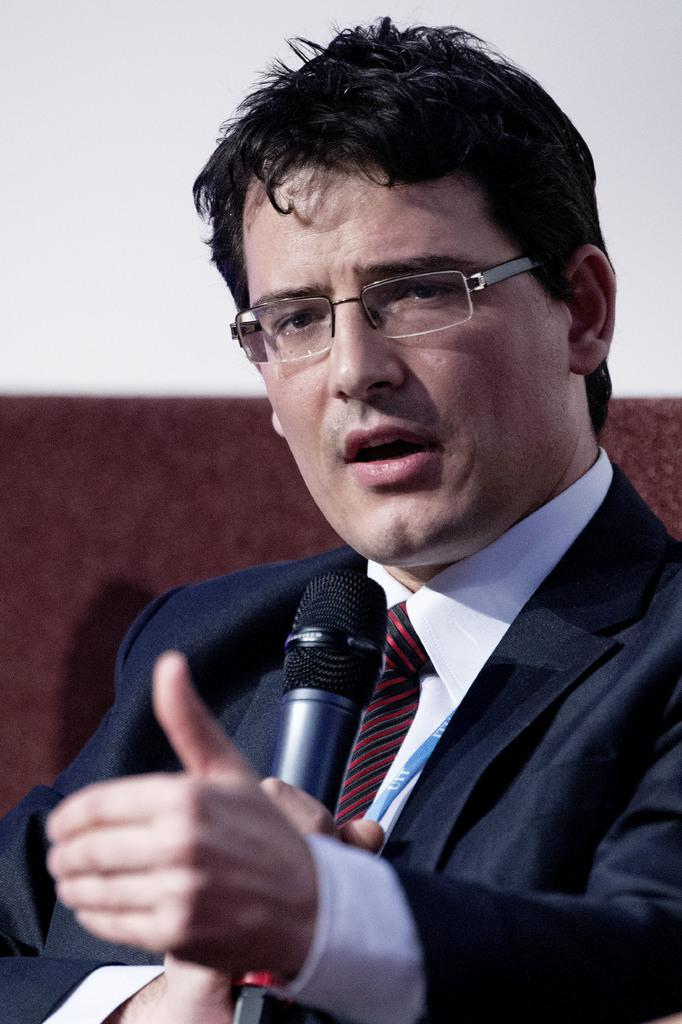Who is the main subject in the image? There is a man in the image. What is the man holding in the image? The man is holding a microphone. What type of clothing is the man wearing on his upper body? The man is wearing a shirt and a jacket. What accessory is the man wearing on his face? The man is wearing glasses. What is the man doing with the microphone? The man is talking with the microphone. What type of quiver is the man using to store his records in the image? There is no quiver or records present in the image. 